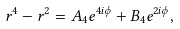<formula> <loc_0><loc_0><loc_500><loc_500>r ^ { 4 } - r ^ { 2 } = A _ { 4 } e ^ { 4 i \phi } + B _ { 4 } e ^ { 2 i \phi } ,</formula> 